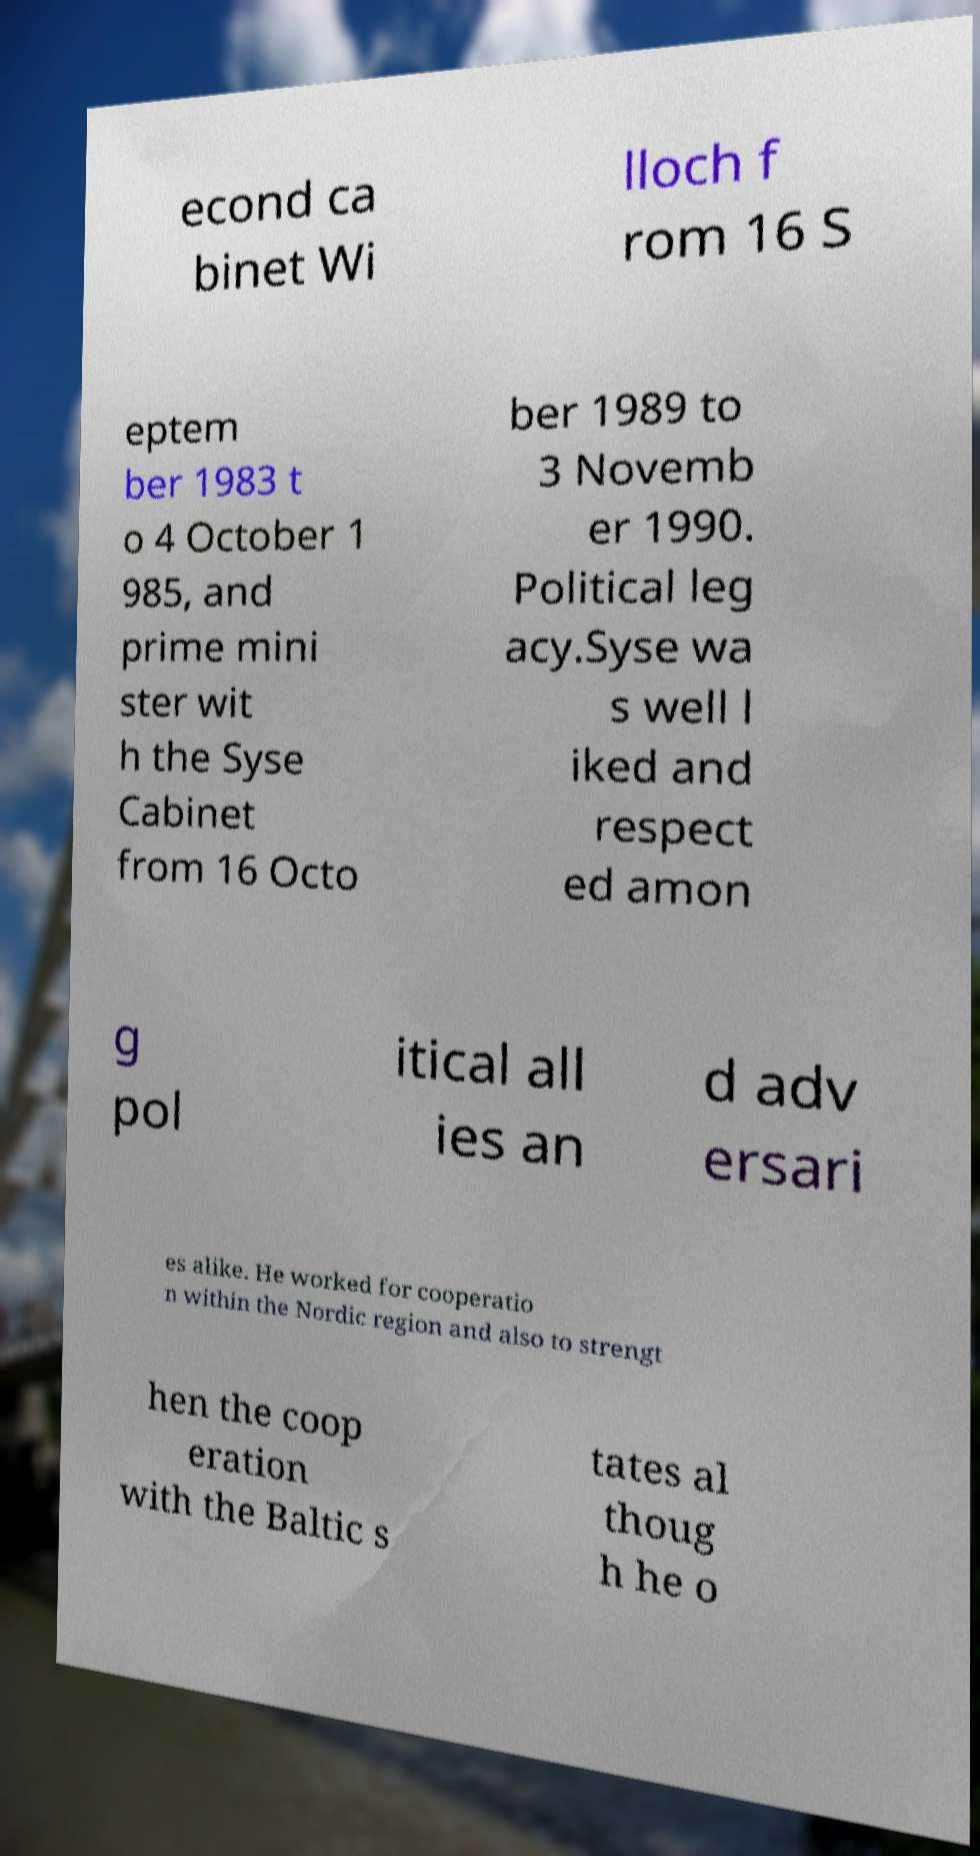What messages or text are displayed in this image? I need them in a readable, typed format. econd ca binet Wi lloch f rom 16 S eptem ber 1983 t o 4 October 1 985, and prime mini ster wit h the Syse Cabinet from 16 Octo ber 1989 to 3 Novemb er 1990. Political leg acy.Syse wa s well l iked and respect ed amon g pol itical all ies an d adv ersari es alike. He worked for cooperatio n within the Nordic region and also to strengt hen the coop eration with the Baltic s tates al thoug h he o 